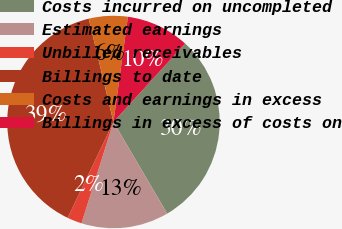Convert chart to OTSL. <chart><loc_0><loc_0><loc_500><loc_500><pie_chart><fcel>Costs incurred on uncompleted<fcel>Estimated earnings<fcel>Unbilled receivables<fcel>Billings to date<fcel>Costs and earnings in excess<fcel>Billings in excess of costs on<nl><fcel>29.77%<fcel>13.31%<fcel>2.23%<fcel>39.17%<fcel>5.92%<fcel>9.61%<nl></chart> 